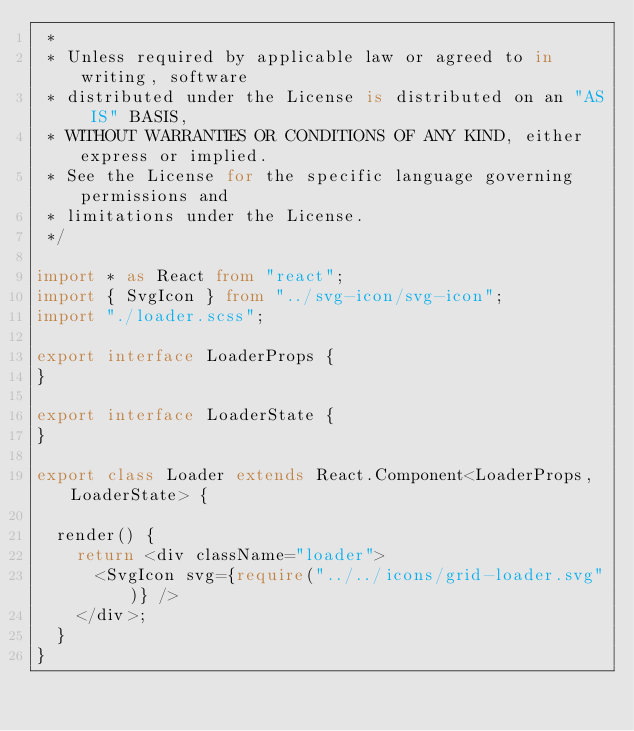Convert code to text. <code><loc_0><loc_0><loc_500><loc_500><_TypeScript_> *
 * Unless required by applicable law or agreed to in writing, software
 * distributed under the License is distributed on an "AS IS" BASIS,
 * WITHOUT WARRANTIES OR CONDITIONS OF ANY KIND, either express or implied.
 * See the License for the specific language governing permissions and
 * limitations under the License.
 */

import * as React from "react";
import { SvgIcon } from "../svg-icon/svg-icon";
import "./loader.scss";

export interface LoaderProps {
}

export interface LoaderState {
}

export class Loader extends React.Component<LoaderProps, LoaderState> {

  render() {
    return <div className="loader">
      <SvgIcon svg={require("../../icons/grid-loader.svg")} />
    </div>;
  }
}
</code> 